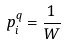Convert formula to latex. <formula><loc_0><loc_0><loc_500><loc_500>p _ { i } ^ { q } = \frac { 1 } { W }</formula> 